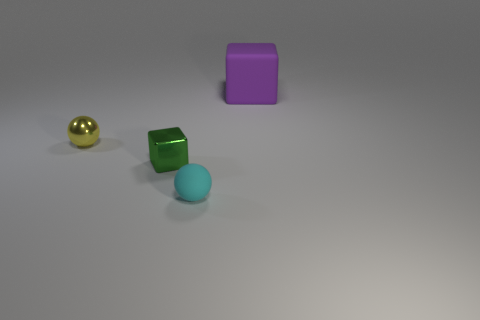There is a object behind the metallic sphere; what size is it?
Ensure brevity in your answer.  Large. The rubber cube is what size?
Offer a very short reply. Large. There is a shiny block; is it the same size as the block to the right of the cyan matte object?
Your response must be concise. No. What is the color of the tiny sphere that is to the right of the tiny sphere left of the green thing?
Offer a terse response. Cyan. Are there the same number of green metallic things that are behind the metal cube and tiny blocks on the left side of the small matte thing?
Keep it short and to the point. No. Do the ball that is behind the tiny cyan rubber sphere and the small green block have the same material?
Offer a very short reply. Yes. What color is the object that is both left of the purple thing and to the right of the tiny metallic block?
Your answer should be compact. Cyan. What number of small metallic objects are behind the block behind the small yellow metal thing?
Keep it short and to the point. 0. There is another tiny object that is the same shape as the small yellow thing; what is it made of?
Ensure brevity in your answer.  Rubber. What color is the large rubber block?
Your answer should be compact. Purple. 